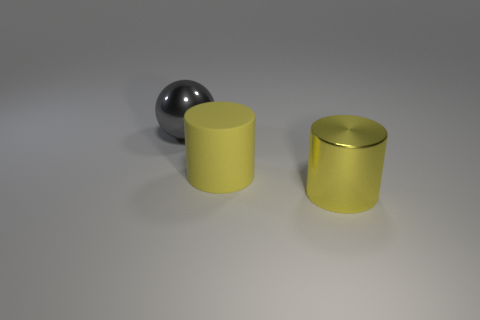Add 3 green things. How many objects exist? 6 Subtract all balls. How many objects are left? 2 Add 2 matte things. How many matte things exist? 3 Subtract 0 blue spheres. How many objects are left? 3 Subtract all large green matte cylinders. Subtract all large shiny things. How many objects are left? 1 Add 1 large spheres. How many large spheres are left? 2 